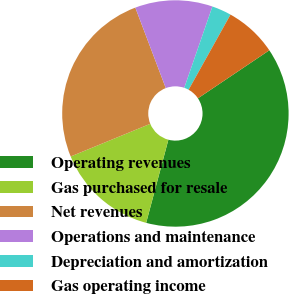Convert chart to OTSL. <chart><loc_0><loc_0><loc_500><loc_500><pie_chart><fcel>Operating revenues<fcel>Gas purchased for resale<fcel>Net revenues<fcel>Operations and maintenance<fcel>Depreciation and amortization<fcel>Gas operating income<nl><fcel>38.58%<fcel>14.64%<fcel>25.44%<fcel>11.06%<fcel>2.79%<fcel>7.48%<nl></chart> 